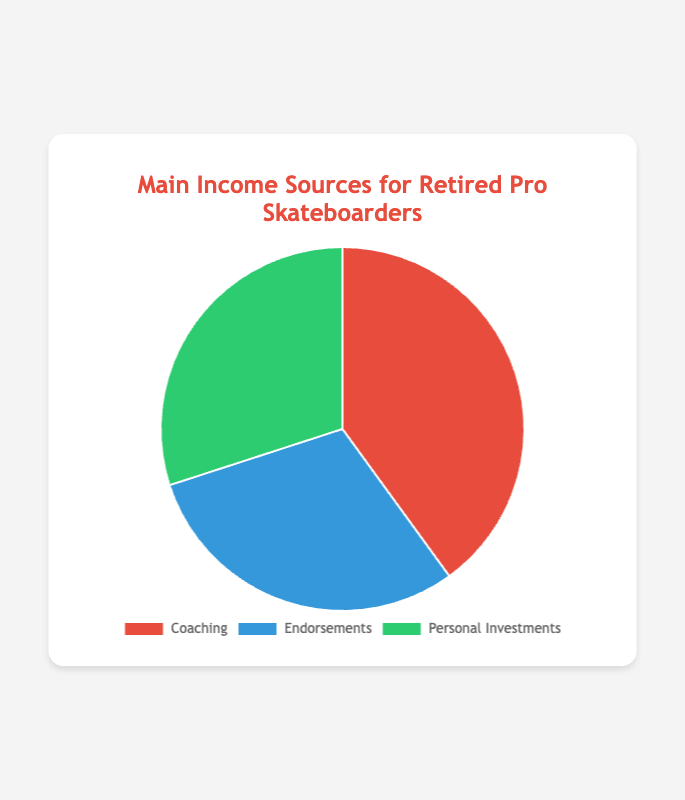What is the main source of income for retired professional skateboarders? From the chart, the segment with the largest percentage represents the main source of income. The "Coaching" segment is the largest with 40%.
Answer: Coaching Which income sources have an equal percentage? The two income sources with the same size (30%) are "Endorsements" and "Personal Investments".
Answer: Endorsements and Personal Investments What is the combined percentage of income from Endorsements and Personal Investments? By summing the percentages from "Endorsements" (30%) and "Personal Investments" (30%), we get 30% + 30% = 60%.
Answer: 60% Which income source is represented by the green color in the chart? The green segment in the chart represents "Personal Investments".
Answer: Personal Investments How much more percentage does Coaching contribute compared to Endorsements? Subtract the percentage of Endorsements (30%) from Coaching (40%). 40% - 30% = 10%.
Answer: 10% If the income sources other than Coaching are combined, what is their total percentage? Sum the percentages of Endorsements (30%) and Personal Investments (30%) to get 30% + 30% = 60%.
Answer: 60% Is there any income source that makes up less than one-third of the total income? Any source under 33.33% is less than one-third. Both Endorsements and Personal Investments make up 30%, so they are less than one-third.
Answer: Yes What's the combined income percentage from sources that make up exactly one-fifth and one-fourth of the total? "Consulting for companies" under Coaching makes up 5% (one-twentieth), and "Social media sponsorships" under Endorsements makes up 10% (one-tenth). Combining 5% + 10% = 15%.
Answer: 15% Which color represents Coaching, and what percentage does it contribute? The red color in the chart represents "Coaching", and it contributes 40%.
Answer: Red, 40% If Coaching's percentage dropped by 10%, how would the percentages compare with Endorsements and Personal Investments? If Coaching drops by 10%, it would be at 30%. Comparing, Coaching (30%), Endorsements (30%), Personal Investments (30%) will all have equal percentages.
Answer: Equal 